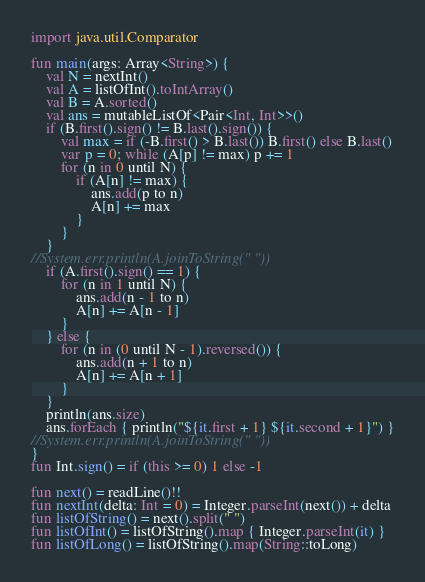<code> <loc_0><loc_0><loc_500><loc_500><_Kotlin_>import java.util.Comparator

fun main(args: Array<String>) {
    val N = nextInt()
    val A = listOfInt().toIntArray()
    val B = A.sorted()
    val ans = mutableListOf<Pair<Int, Int>>()
    if (B.first().sign() != B.last().sign()) {
        val max = if (-B.first() > B.last()) B.first() else B.last()
        var p = 0; while (A[p] != max) p += 1
        for (n in 0 until N) {
            if (A[n] != max) {
                ans.add(p to n)
                A[n] += max
            }
        }
    }
//System.err.println(A.joinToString(" "))
    if (A.first().sign() == 1) {
        for (n in 1 until N) {
            ans.add(n - 1 to n)
            A[n] += A[n - 1]
        }
    } else {
        for (n in (0 until N - 1).reversed()) {
            ans.add(n + 1 to n)
            A[n] += A[n + 1]
        }
    }
    println(ans.size)
    ans.forEach { println("${it.first + 1} ${it.second + 1}") }
//System.err.println(A.joinToString(" "))
}
fun Int.sign() = if (this >= 0) 1 else -1

fun next() = readLine()!!
fun nextInt(delta: Int = 0) = Integer.parseInt(next()) + delta
fun listOfString() = next().split(" ")
fun listOfInt() = listOfString().map { Integer.parseInt(it) }
fun listOfLong() = listOfString().map(String::toLong)
</code> 